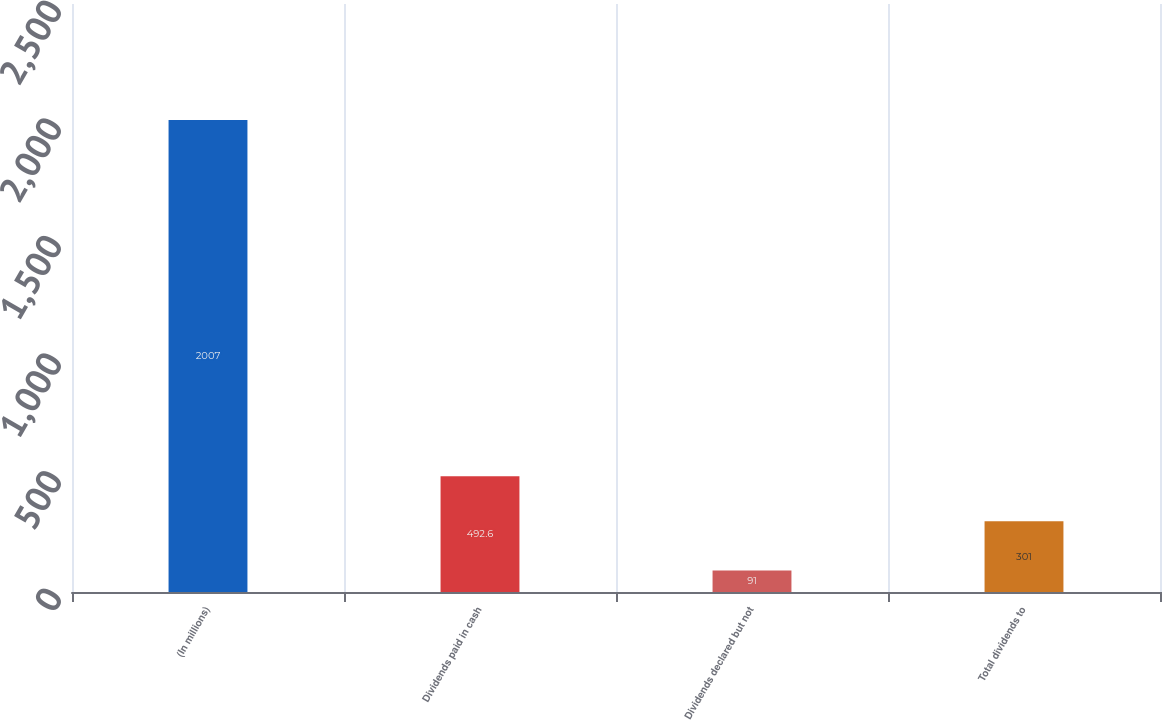<chart> <loc_0><loc_0><loc_500><loc_500><bar_chart><fcel>(In millions)<fcel>Dividends paid in cash<fcel>Dividends declared but not<fcel>Total dividends to<nl><fcel>2007<fcel>492.6<fcel>91<fcel>301<nl></chart> 